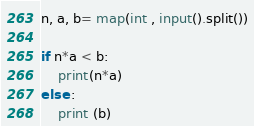Convert code to text. <code><loc_0><loc_0><loc_500><loc_500><_Python_>n, a, b= map(int , input().split())

if n*a < b:
    print(n*a)
else :
    print (b)</code> 